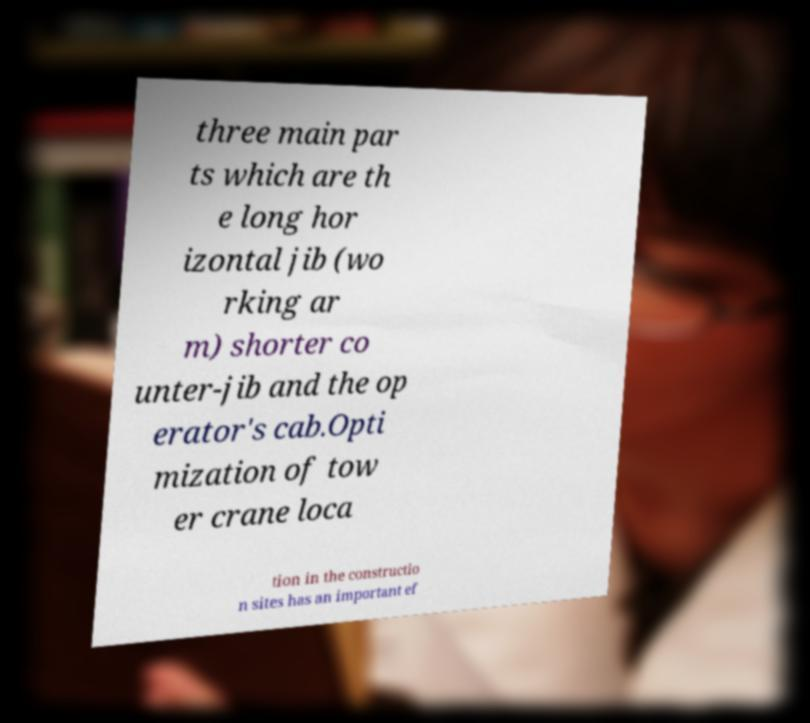Please read and relay the text visible in this image. What does it say? three main par ts which are th e long hor izontal jib (wo rking ar m) shorter co unter-jib and the op erator's cab.Opti mization of tow er crane loca tion in the constructio n sites has an important ef 